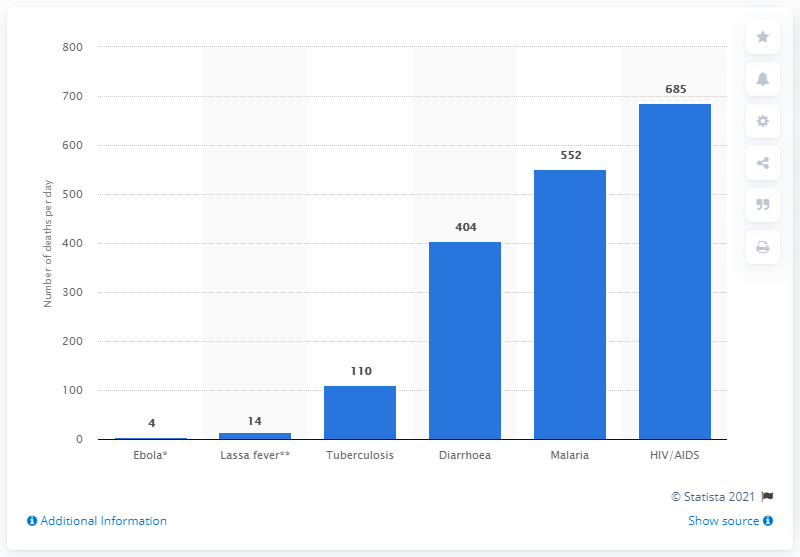Identify some key points in this picture. Malaria causes an average of 552 deaths per day in West African countries. 